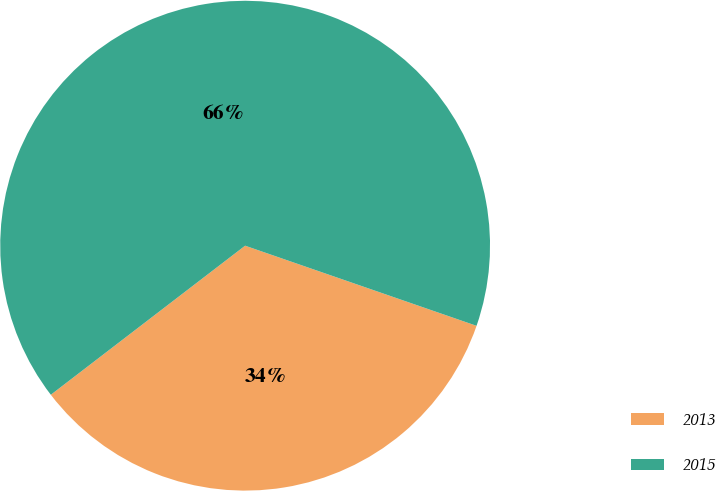Convert chart to OTSL. <chart><loc_0><loc_0><loc_500><loc_500><pie_chart><fcel>2013<fcel>2015<nl><fcel>34.28%<fcel>65.72%<nl></chart> 